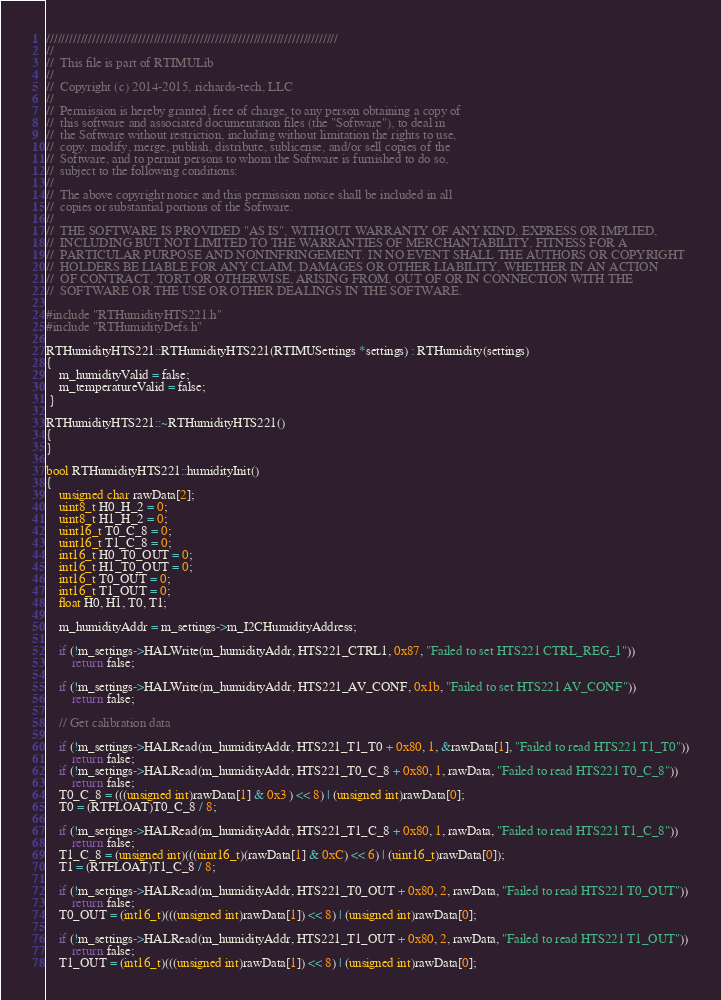Convert code to text. <code><loc_0><loc_0><loc_500><loc_500><_C++_>////////////////////////////////////////////////////////////////////////////
//
//  This file is part of RTIMULib
//
//  Copyright (c) 2014-2015, richards-tech, LLC
//
//  Permission is hereby granted, free of charge, to any person obtaining a copy of
//  this software and associated documentation files (the "Software"), to deal in
//  the Software without restriction, including without limitation the rights to use,
//  copy, modify, merge, publish, distribute, sublicense, and/or sell copies of the
//  Software, and to permit persons to whom the Software is furnished to do so,
//  subject to the following conditions:
//
//  The above copyright notice and this permission notice shall be included in all
//  copies or substantial portions of the Software.
//
//  THE SOFTWARE IS PROVIDED "AS IS", WITHOUT WARRANTY OF ANY KIND, EXPRESS OR IMPLIED,
//  INCLUDING BUT NOT LIMITED TO THE WARRANTIES OF MERCHANTABILITY, FITNESS FOR A
//  PARTICULAR PURPOSE AND NONINFRINGEMENT. IN NO EVENT SHALL THE AUTHORS OR COPYRIGHT
//  HOLDERS BE LIABLE FOR ANY CLAIM, DAMAGES OR OTHER LIABILITY, WHETHER IN AN ACTION
//  OF CONTRACT, TORT OR OTHERWISE, ARISING FROM, OUT OF OR IN CONNECTION WITH THE
//  SOFTWARE OR THE USE OR OTHER DEALINGS IN THE SOFTWARE.

#include "RTHumidityHTS221.h"
#include "RTHumidityDefs.h"

RTHumidityHTS221::RTHumidityHTS221(RTIMUSettings *settings) : RTHumidity(settings)
{
    m_humidityValid = false;
    m_temperatureValid = false;
 }

RTHumidityHTS221::~RTHumidityHTS221()
{
}

bool RTHumidityHTS221::humidityInit()
{
    unsigned char rawData[2];
    uint8_t H0_H_2 = 0;
    uint8_t H1_H_2 = 0;
    uint16_t T0_C_8 = 0;
    uint16_t T1_C_8 = 0;
    int16_t H0_T0_OUT = 0;
    int16_t H1_T0_OUT = 0;
    int16_t T0_OUT = 0;
    int16_t T1_OUT = 0;
    float H0, H1, T0, T1;

    m_humidityAddr = m_settings->m_I2CHumidityAddress;

    if (!m_settings->HALWrite(m_humidityAddr, HTS221_CTRL1, 0x87, "Failed to set HTS221 CTRL_REG_1"))
        return false;

    if (!m_settings->HALWrite(m_humidityAddr, HTS221_AV_CONF, 0x1b, "Failed to set HTS221 AV_CONF"))
        return false;

    // Get calibration data

    if (!m_settings->HALRead(m_humidityAddr, HTS221_T1_T0 + 0x80, 1, &rawData[1], "Failed to read HTS221 T1_T0"))
        return false;
    if (!m_settings->HALRead(m_humidityAddr, HTS221_T0_C_8 + 0x80, 1, rawData, "Failed to read HTS221 T0_C_8"))
        return false;
    T0_C_8 = (((unsigned int)rawData[1] & 0x3 ) << 8) | (unsigned int)rawData[0];
    T0 = (RTFLOAT)T0_C_8 / 8;

    if (!m_settings->HALRead(m_humidityAddr, HTS221_T1_C_8 + 0x80, 1, rawData, "Failed to read HTS221 T1_C_8"))
        return false;
    T1_C_8 = (unsigned int)(((uint16_t)(rawData[1] & 0xC) << 6) | (uint16_t)rawData[0]);
    T1 = (RTFLOAT)T1_C_8 / 8;

    if (!m_settings->HALRead(m_humidityAddr, HTS221_T0_OUT + 0x80, 2, rawData, "Failed to read HTS221 T0_OUT"))
        return false;
    T0_OUT = (int16_t)(((unsigned int)rawData[1]) << 8) | (unsigned int)rawData[0];

    if (!m_settings->HALRead(m_humidityAddr, HTS221_T1_OUT + 0x80, 2, rawData, "Failed to read HTS221 T1_OUT"))
        return false;
    T1_OUT = (int16_t)(((unsigned int)rawData[1]) << 8) | (unsigned int)rawData[0];
</code> 